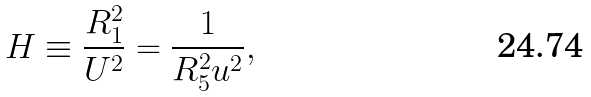Convert formula to latex. <formula><loc_0><loc_0><loc_500><loc_500>H \equiv \frac { R _ { 1 } ^ { 2 } } { U ^ { 2 } } = \frac { 1 } { R _ { 5 } ^ { 2 } u ^ { 2 } } ,</formula> 